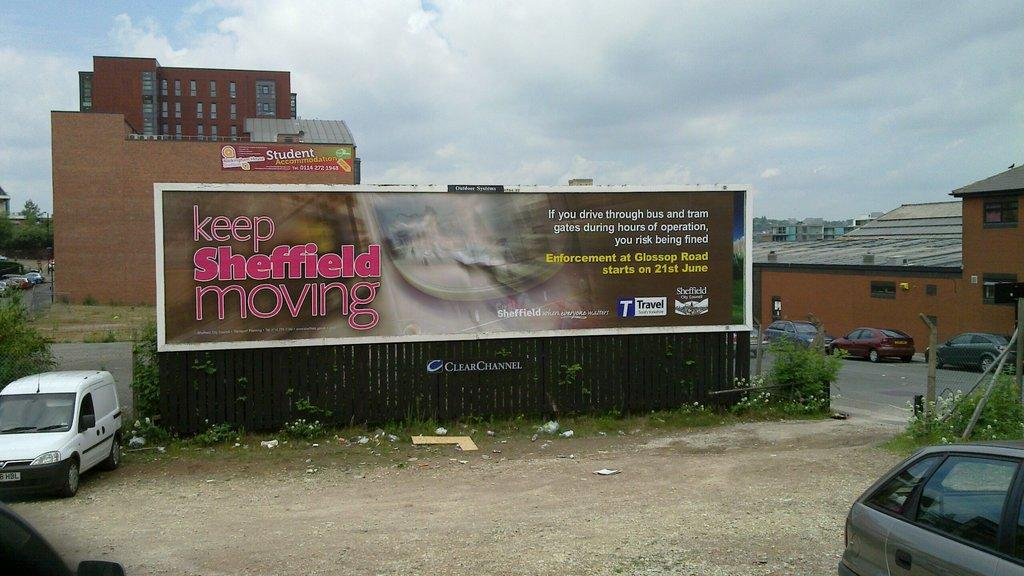<image>
Describe the image concisely. the word enforcement is on the large sign outside 